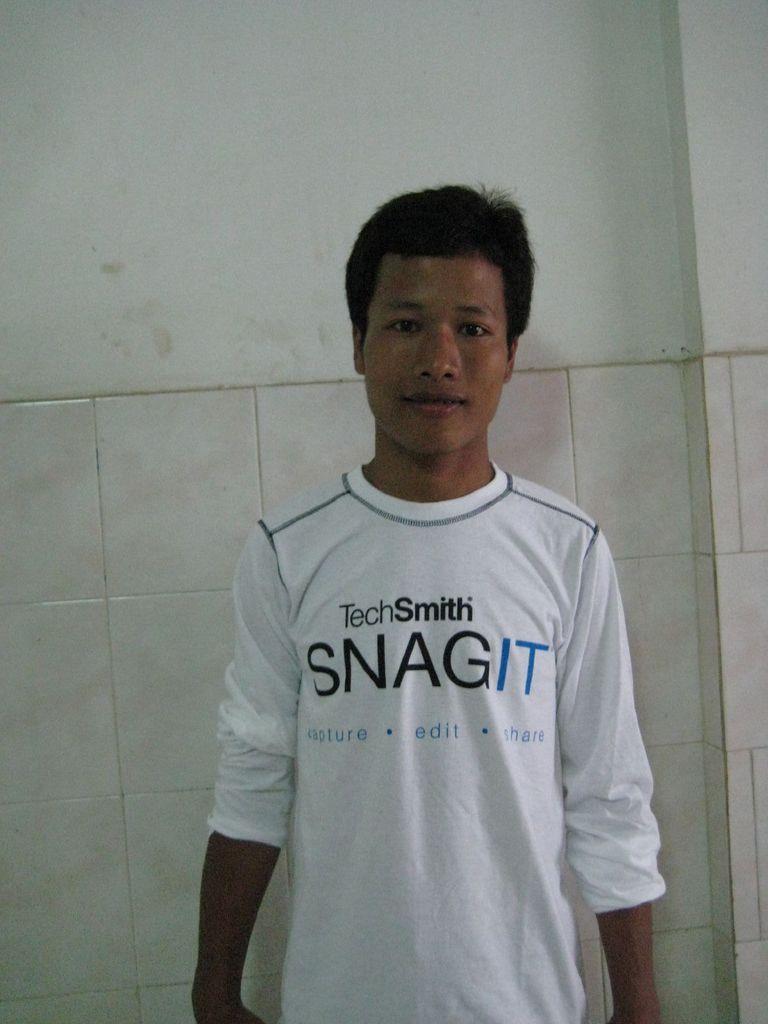Could you give a brief overview of what you see in this image? As we can see in the image in front there is a man who is standing and wearing white colour tshirt on which its written "Techsmith Snagit Capture Edit Share". Behind him there is a wall and tiles which are of white colour. 